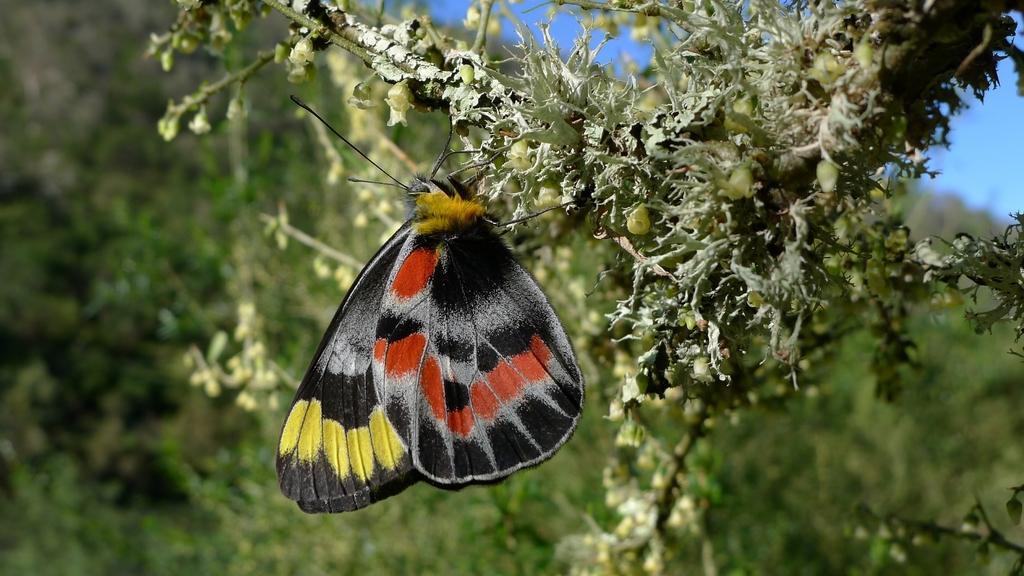How would you summarize this image in a sentence or two? In this image there is a butterfly sucking the juice from the flower. In the background there are so many trees. At the top there is the sky. At the top there is a plant to which there are flowers. 